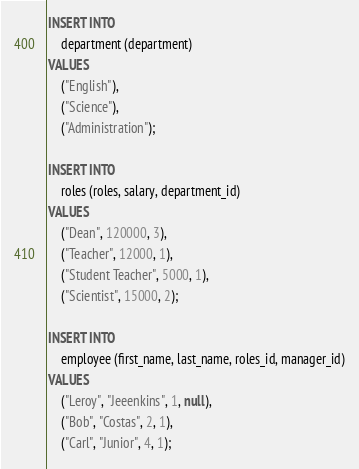<code> <loc_0><loc_0><loc_500><loc_500><_SQL_>INSERT INTO
    department (department)
VALUES
    ("English"),
    ("Science"),
    ("Administration");

INSERT INTO 
    roles (roles, salary, department_id)
VALUES
    ("Dean", 120000, 3),
    ("Teacher", 12000, 1),
    ("Student Teacher", 5000, 1),
    ("Scientist", 15000, 2);

INSERT INTO 
    employee (first_name, last_name, roles_id, manager_id)
VALUES
    ("Leroy", "Jeeenkins", 1, null),
    ("Bob", "Costas", 2, 1),
    ("Carl", "Junior", 4, 1);</code> 